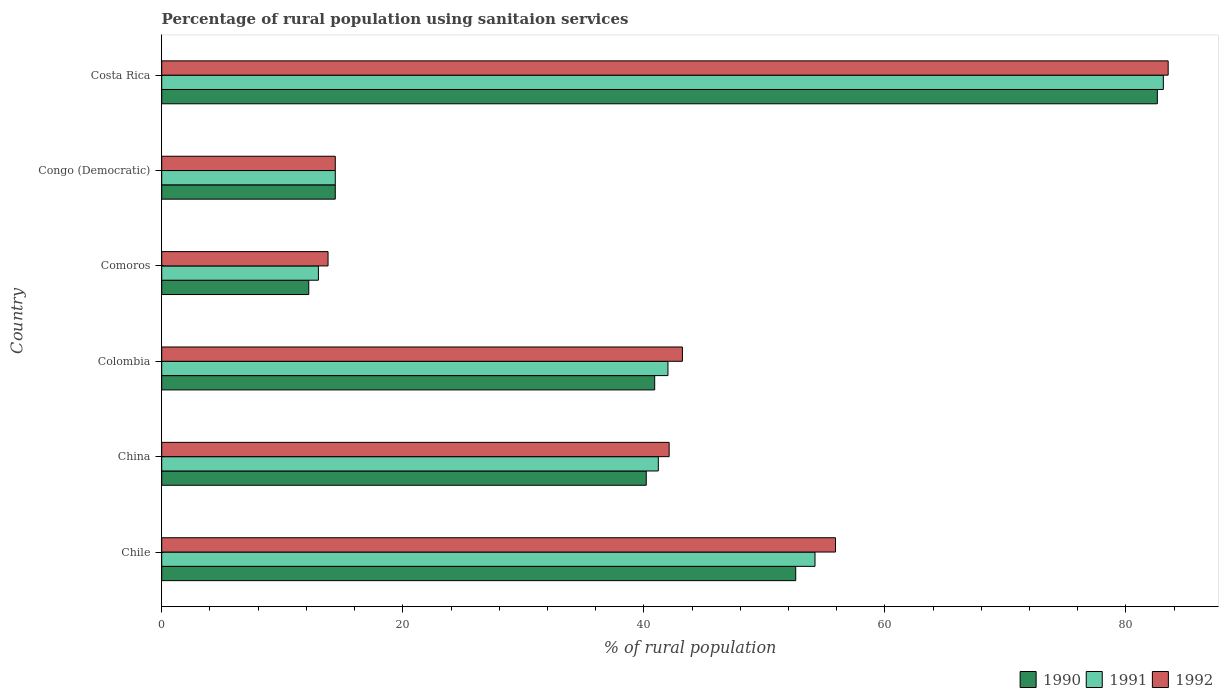How many groups of bars are there?
Your response must be concise. 6. What is the label of the 5th group of bars from the top?
Keep it short and to the point. China. What is the percentage of rural population using sanitaion services in 1992 in Costa Rica?
Your answer should be compact. 83.5. Across all countries, what is the maximum percentage of rural population using sanitaion services in 1990?
Provide a succinct answer. 82.6. Across all countries, what is the minimum percentage of rural population using sanitaion services in 1991?
Ensure brevity in your answer.  13. In which country was the percentage of rural population using sanitaion services in 1991 minimum?
Your answer should be very brief. Comoros. What is the total percentage of rural population using sanitaion services in 1990 in the graph?
Your answer should be very brief. 242.9. What is the difference between the percentage of rural population using sanitaion services in 1991 in China and that in Congo (Democratic)?
Your response must be concise. 26.8. What is the difference between the percentage of rural population using sanitaion services in 1990 in China and the percentage of rural population using sanitaion services in 1992 in Chile?
Make the answer very short. -15.7. What is the average percentage of rural population using sanitaion services in 1990 per country?
Offer a terse response. 40.48. What is the difference between the percentage of rural population using sanitaion services in 1991 and percentage of rural population using sanitaion services in 1990 in Chile?
Provide a short and direct response. 1.6. What is the ratio of the percentage of rural population using sanitaion services in 1992 in Congo (Democratic) to that in Costa Rica?
Offer a terse response. 0.17. Is the percentage of rural population using sanitaion services in 1991 in Chile less than that in Costa Rica?
Give a very brief answer. Yes. Is the difference between the percentage of rural population using sanitaion services in 1991 in China and Colombia greater than the difference between the percentage of rural population using sanitaion services in 1990 in China and Colombia?
Give a very brief answer. No. What is the difference between the highest and the second highest percentage of rural population using sanitaion services in 1990?
Offer a very short reply. 30. What is the difference between the highest and the lowest percentage of rural population using sanitaion services in 1990?
Give a very brief answer. 70.4. In how many countries, is the percentage of rural population using sanitaion services in 1992 greater than the average percentage of rural population using sanitaion services in 1992 taken over all countries?
Keep it short and to the point. 3. Is the sum of the percentage of rural population using sanitaion services in 1992 in China and Costa Rica greater than the maximum percentage of rural population using sanitaion services in 1990 across all countries?
Your response must be concise. Yes. How many countries are there in the graph?
Give a very brief answer. 6. Are the values on the major ticks of X-axis written in scientific E-notation?
Ensure brevity in your answer.  No. Does the graph contain grids?
Offer a very short reply. No. Where does the legend appear in the graph?
Offer a very short reply. Bottom right. How many legend labels are there?
Provide a succinct answer. 3. What is the title of the graph?
Your response must be concise. Percentage of rural population using sanitaion services. What is the label or title of the X-axis?
Your answer should be very brief. % of rural population. What is the label or title of the Y-axis?
Provide a succinct answer. Country. What is the % of rural population in 1990 in Chile?
Offer a terse response. 52.6. What is the % of rural population in 1991 in Chile?
Ensure brevity in your answer.  54.2. What is the % of rural population of 1992 in Chile?
Make the answer very short. 55.9. What is the % of rural population in 1990 in China?
Keep it short and to the point. 40.2. What is the % of rural population in 1991 in China?
Your response must be concise. 41.2. What is the % of rural population of 1992 in China?
Give a very brief answer. 42.1. What is the % of rural population of 1990 in Colombia?
Give a very brief answer. 40.9. What is the % of rural population in 1992 in Colombia?
Keep it short and to the point. 43.2. What is the % of rural population of 1991 in Comoros?
Your answer should be compact. 13. What is the % of rural population of 1992 in Comoros?
Ensure brevity in your answer.  13.8. What is the % of rural population in 1991 in Congo (Democratic)?
Your response must be concise. 14.4. What is the % of rural population in 1990 in Costa Rica?
Your answer should be very brief. 82.6. What is the % of rural population in 1991 in Costa Rica?
Provide a succinct answer. 83.1. What is the % of rural population of 1992 in Costa Rica?
Keep it short and to the point. 83.5. Across all countries, what is the maximum % of rural population in 1990?
Provide a short and direct response. 82.6. Across all countries, what is the maximum % of rural population of 1991?
Ensure brevity in your answer.  83.1. Across all countries, what is the maximum % of rural population in 1992?
Your response must be concise. 83.5. What is the total % of rural population in 1990 in the graph?
Offer a terse response. 242.9. What is the total % of rural population of 1991 in the graph?
Provide a short and direct response. 247.9. What is the total % of rural population in 1992 in the graph?
Your answer should be compact. 252.9. What is the difference between the % of rural population in 1990 in Chile and that in China?
Provide a succinct answer. 12.4. What is the difference between the % of rural population in 1992 in Chile and that in China?
Make the answer very short. 13.8. What is the difference between the % of rural population in 1990 in Chile and that in Colombia?
Keep it short and to the point. 11.7. What is the difference between the % of rural population of 1991 in Chile and that in Colombia?
Your response must be concise. 12.2. What is the difference between the % of rural population of 1990 in Chile and that in Comoros?
Ensure brevity in your answer.  40.4. What is the difference between the % of rural population of 1991 in Chile and that in Comoros?
Provide a succinct answer. 41.2. What is the difference between the % of rural population of 1992 in Chile and that in Comoros?
Your answer should be compact. 42.1. What is the difference between the % of rural population in 1990 in Chile and that in Congo (Democratic)?
Provide a succinct answer. 38.2. What is the difference between the % of rural population of 1991 in Chile and that in Congo (Democratic)?
Your response must be concise. 39.8. What is the difference between the % of rural population in 1992 in Chile and that in Congo (Democratic)?
Make the answer very short. 41.5. What is the difference between the % of rural population of 1990 in Chile and that in Costa Rica?
Your answer should be very brief. -30. What is the difference between the % of rural population in 1991 in Chile and that in Costa Rica?
Make the answer very short. -28.9. What is the difference between the % of rural population in 1992 in Chile and that in Costa Rica?
Ensure brevity in your answer.  -27.6. What is the difference between the % of rural population in 1990 in China and that in Colombia?
Your answer should be compact. -0.7. What is the difference between the % of rural population in 1991 in China and that in Colombia?
Keep it short and to the point. -0.8. What is the difference between the % of rural population in 1990 in China and that in Comoros?
Provide a short and direct response. 28. What is the difference between the % of rural population in 1991 in China and that in Comoros?
Provide a succinct answer. 28.2. What is the difference between the % of rural population of 1992 in China and that in Comoros?
Keep it short and to the point. 28.3. What is the difference between the % of rural population of 1990 in China and that in Congo (Democratic)?
Offer a terse response. 25.8. What is the difference between the % of rural population in 1991 in China and that in Congo (Democratic)?
Ensure brevity in your answer.  26.8. What is the difference between the % of rural population of 1992 in China and that in Congo (Democratic)?
Offer a very short reply. 27.7. What is the difference between the % of rural population in 1990 in China and that in Costa Rica?
Give a very brief answer. -42.4. What is the difference between the % of rural population of 1991 in China and that in Costa Rica?
Your response must be concise. -41.9. What is the difference between the % of rural population of 1992 in China and that in Costa Rica?
Your answer should be very brief. -41.4. What is the difference between the % of rural population in 1990 in Colombia and that in Comoros?
Your answer should be compact. 28.7. What is the difference between the % of rural population of 1991 in Colombia and that in Comoros?
Your answer should be compact. 29. What is the difference between the % of rural population in 1992 in Colombia and that in Comoros?
Your answer should be compact. 29.4. What is the difference between the % of rural population in 1990 in Colombia and that in Congo (Democratic)?
Provide a succinct answer. 26.5. What is the difference between the % of rural population of 1991 in Colombia and that in Congo (Democratic)?
Keep it short and to the point. 27.6. What is the difference between the % of rural population in 1992 in Colombia and that in Congo (Democratic)?
Provide a succinct answer. 28.8. What is the difference between the % of rural population in 1990 in Colombia and that in Costa Rica?
Provide a succinct answer. -41.7. What is the difference between the % of rural population of 1991 in Colombia and that in Costa Rica?
Keep it short and to the point. -41.1. What is the difference between the % of rural population of 1992 in Colombia and that in Costa Rica?
Make the answer very short. -40.3. What is the difference between the % of rural population in 1990 in Comoros and that in Congo (Democratic)?
Your response must be concise. -2.2. What is the difference between the % of rural population in 1991 in Comoros and that in Congo (Democratic)?
Offer a very short reply. -1.4. What is the difference between the % of rural population of 1990 in Comoros and that in Costa Rica?
Your answer should be compact. -70.4. What is the difference between the % of rural population of 1991 in Comoros and that in Costa Rica?
Offer a very short reply. -70.1. What is the difference between the % of rural population in 1992 in Comoros and that in Costa Rica?
Your answer should be compact. -69.7. What is the difference between the % of rural population in 1990 in Congo (Democratic) and that in Costa Rica?
Provide a short and direct response. -68.2. What is the difference between the % of rural population in 1991 in Congo (Democratic) and that in Costa Rica?
Make the answer very short. -68.7. What is the difference between the % of rural population of 1992 in Congo (Democratic) and that in Costa Rica?
Give a very brief answer. -69.1. What is the difference between the % of rural population of 1990 in Chile and the % of rural population of 1991 in China?
Provide a succinct answer. 11.4. What is the difference between the % of rural population in 1990 in Chile and the % of rural population in 1992 in China?
Offer a very short reply. 10.5. What is the difference between the % of rural population of 1990 in Chile and the % of rural population of 1991 in Colombia?
Offer a very short reply. 10.6. What is the difference between the % of rural population of 1990 in Chile and the % of rural population of 1992 in Colombia?
Make the answer very short. 9.4. What is the difference between the % of rural population of 1990 in Chile and the % of rural population of 1991 in Comoros?
Offer a terse response. 39.6. What is the difference between the % of rural population in 1990 in Chile and the % of rural population in 1992 in Comoros?
Ensure brevity in your answer.  38.8. What is the difference between the % of rural population in 1991 in Chile and the % of rural population in 1992 in Comoros?
Your answer should be compact. 40.4. What is the difference between the % of rural population of 1990 in Chile and the % of rural population of 1991 in Congo (Democratic)?
Ensure brevity in your answer.  38.2. What is the difference between the % of rural population in 1990 in Chile and the % of rural population in 1992 in Congo (Democratic)?
Your answer should be compact. 38.2. What is the difference between the % of rural population of 1991 in Chile and the % of rural population of 1992 in Congo (Democratic)?
Your answer should be very brief. 39.8. What is the difference between the % of rural population in 1990 in Chile and the % of rural population in 1991 in Costa Rica?
Offer a terse response. -30.5. What is the difference between the % of rural population of 1990 in Chile and the % of rural population of 1992 in Costa Rica?
Keep it short and to the point. -30.9. What is the difference between the % of rural population in 1991 in Chile and the % of rural population in 1992 in Costa Rica?
Your answer should be compact. -29.3. What is the difference between the % of rural population of 1990 in China and the % of rural population of 1992 in Colombia?
Ensure brevity in your answer.  -3. What is the difference between the % of rural population in 1991 in China and the % of rural population in 1992 in Colombia?
Make the answer very short. -2. What is the difference between the % of rural population in 1990 in China and the % of rural population in 1991 in Comoros?
Offer a very short reply. 27.2. What is the difference between the % of rural population of 1990 in China and the % of rural population of 1992 in Comoros?
Provide a short and direct response. 26.4. What is the difference between the % of rural population in 1991 in China and the % of rural population in 1992 in Comoros?
Ensure brevity in your answer.  27.4. What is the difference between the % of rural population in 1990 in China and the % of rural population in 1991 in Congo (Democratic)?
Ensure brevity in your answer.  25.8. What is the difference between the % of rural population of 1990 in China and the % of rural population of 1992 in Congo (Democratic)?
Offer a terse response. 25.8. What is the difference between the % of rural population of 1991 in China and the % of rural population of 1992 in Congo (Democratic)?
Give a very brief answer. 26.8. What is the difference between the % of rural population of 1990 in China and the % of rural population of 1991 in Costa Rica?
Your answer should be very brief. -42.9. What is the difference between the % of rural population of 1990 in China and the % of rural population of 1992 in Costa Rica?
Ensure brevity in your answer.  -43.3. What is the difference between the % of rural population of 1991 in China and the % of rural population of 1992 in Costa Rica?
Make the answer very short. -42.3. What is the difference between the % of rural population in 1990 in Colombia and the % of rural population in 1991 in Comoros?
Offer a very short reply. 27.9. What is the difference between the % of rural population in 1990 in Colombia and the % of rural population in 1992 in Comoros?
Your answer should be compact. 27.1. What is the difference between the % of rural population in 1991 in Colombia and the % of rural population in 1992 in Comoros?
Your answer should be compact. 28.2. What is the difference between the % of rural population of 1990 in Colombia and the % of rural population of 1992 in Congo (Democratic)?
Make the answer very short. 26.5. What is the difference between the % of rural population of 1991 in Colombia and the % of rural population of 1992 in Congo (Democratic)?
Keep it short and to the point. 27.6. What is the difference between the % of rural population in 1990 in Colombia and the % of rural population in 1991 in Costa Rica?
Ensure brevity in your answer.  -42.2. What is the difference between the % of rural population of 1990 in Colombia and the % of rural population of 1992 in Costa Rica?
Offer a terse response. -42.6. What is the difference between the % of rural population of 1991 in Colombia and the % of rural population of 1992 in Costa Rica?
Provide a short and direct response. -41.5. What is the difference between the % of rural population in 1990 in Comoros and the % of rural population in 1992 in Congo (Democratic)?
Keep it short and to the point. -2.2. What is the difference between the % of rural population in 1991 in Comoros and the % of rural population in 1992 in Congo (Democratic)?
Provide a short and direct response. -1.4. What is the difference between the % of rural population in 1990 in Comoros and the % of rural population in 1991 in Costa Rica?
Make the answer very short. -70.9. What is the difference between the % of rural population in 1990 in Comoros and the % of rural population in 1992 in Costa Rica?
Offer a terse response. -71.3. What is the difference between the % of rural population of 1991 in Comoros and the % of rural population of 1992 in Costa Rica?
Keep it short and to the point. -70.5. What is the difference between the % of rural population in 1990 in Congo (Democratic) and the % of rural population in 1991 in Costa Rica?
Your answer should be compact. -68.7. What is the difference between the % of rural population in 1990 in Congo (Democratic) and the % of rural population in 1992 in Costa Rica?
Your response must be concise. -69.1. What is the difference between the % of rural population of 1991 in Congo (Democratic) and the % of rural population of 1992 in Costa Rica?
Offer a very short reply. -69.1. What is the average % of rural population in 1990 per country?
Offer a terse response. 40.48. What is the average % of rural population of 1991 per country?
Keep it short and to the point. 41.32. What is the average % of rural population of 1992 per country?
Provide a short and direct response. 42.15. What is the difference between the % of rural population in 1990 and % of rural population in 1991 in Chile?
Keep it short and to the point. -1.6. What is the difference between the % of rural population in 1991 and % of rural population in 1992 in Chile?
Offer a very short reply. -1.7. What is the difference between the % of rural population of 1990 and % of rural population of 1992 in Colombia?
Your response must be concise. -2.3. What is the difference between the % of rural population in 1991 and % of rural population in 1992 in Colombia?
Provide a succinct answer. -1.2. What is the difference between the % of rural population in 1991 and % of rural population in 1992 in Comoros?
Provide a short and direct response. -0.8. What is the difference between the % of rural population in 1990 and % of rural population in 1991 in Congo (Democratic)?
Your response must be concise. 0. What is the difference between the % of rural population in 1990 and % of rural population in 1992 in Congo (Democratic)?
Offer a very short reply. 0. What is the difference between the % of rural population of 1990 and % of rural population of 1991 in Costa Rica?
Offer a very short reply. -0.5. What is the ratio of the % of rural population of 1990 in Chile to that in China?
Offer a terse response. 1.31. What is the ratio of the % of rural population of 1991 in Chile to that in China?
Provide a short and direct response. 1.32. What is the ratio of the % of rural population in 1992 in Chile to that in China?
Keep it short and to the point. 1.33. What is the ratio of the % of rural population in 1990 in Chile to that in Colombia?
Your response must be concise. 1.29. What is the ratio of the % of rural population in 1991 in Chile to that in Colombia?
Give a very brief answer. 1.29. What is the ratio of the % of rural population in 1992 in Chile to that in Colombia?
Your response must be concise. 1.29. What is the ratio of the % of rural population of 1990 in Chile to that in Comoros?
Provide a succinct answer. 4.31. What is the ratio of the % of rural population of 1991 in Chile to that in Comoros?
Your answer should be compact. 4.17. What is the ratio of the % of rural population of 1992 in Chile to that in Comoros?
Your answer should be very brief. 4.05. What is the ratio of the % of rural population in 1990 in Chile to that in Congo (Democratic)?
Offer a very short reply. 3.65. What is the ratio of the % of rural population of 1991 in Chile to that in Congo (Democratic)?
Ensure brevity in your answer.  3.76. What is the ratio of the % of rural population of 1992 in Chile to that in Congo (Democratic)?
Provide a succinct answer. 3.88. What is the ratio of the % of rural population in 1990 in Chile to that in Costa Rica?
Provide a short and direct response. 0.64. What is the ratio of the % of rural population in 1991 in Chile to that in Costa Rica?
Ensure brevity in your answer.  0.65. What is the ratio of the % of rural population in 1992 in Chile to that in Costa Rica?
Offer a very short reply. 0.67. What is the ratio of the % of rural population of 1990 in China to that in Colombia?
Ensure brevity in your answer.  0.98. What is the ratio of the % of rural population in 1991 in China to that in Colombia?
Make the answer very short. 0.98. What is the ratio of the % of rural population of 1992 in China to that in Colombia?
Offer a very short reply. 0.97. What is the ratio of the % of rural population of 1990 in China to that in Comoros?
Keep it short and to the point. 3.3. What is the ratio of the % of rural population in 1991 in China to that in Comoros?
Offer a very short reply. 3.17. What is the ratio of the % of rural population in 1992 in China to that in Comoros?
Keep it short and to the point. 3.05. What is the ratio of the % of rural population of 1990 in China to that in Congo (Democratic)?
Ensure brevity in your answer.  2.79. What is the ratio of the % of rural population in 1991 in China to that in Congo (Democratic)?
Give a very brief answer. 2.86. What is the ratio of the % of rural population in 1992 in China to that in Congo (Democratic)?
Provide a short and direct response. 2.92. What is the ratio of the % of rural population in 1990 in China to that in Costa Rica?
Give a very brief answer. 0.49. What is the ratio of the % of rural population in 1991 in China to that in Costa Rica?
Offer a very short reply. 0.5. What is the ratio of the % of rural population in 1992 in China to that in Costa Rica?
Ensure brevity in your answer.  0.5. What is the ratio of the % of rural population in 1990 in Colombia to that in Comoros?
Offer a terse response. 3.35. What is the ratio of the % of rural population of 1991 in Colombia to that in Comoros?
Offer a very short reply. 3.23. What is the ratio of the % of rural population of 1992 in Colombia to that in Comoros?
Provide a short and direct response. 3.13. What is the ratio of the % of rural population in 1990 in Colombia to that in Congo (Democratic)?
Provide a succinct answer. 2.84. What is the ratio of the % of rural population in 1991 in Colombia to that in Congo (Democratic)?
Provide a short and direct response. 2.92. What is the ratio of the % of rural population of 1992 in Colombia to that in Congo (Democratic)?
Ensure brevity in your answer.  3. What is the ratio of the % of rural population in 1990 in Colombia to that in Costa Rica?
Provide a succinct answer. 0.5. What is the ratio of the % of rural population in 1991 in Colombia to that in Costa Rica?
Your answer should be very brief. 0.51. What is the ratio of the % of rural population in 1992 in Colombia to that in Costa Rica?
Give a very brief answer. 0.52. What is the ratio of the % of rural population of 1990 in Comoros to that in Congo (Democratic)?
Provide a short and direct response. 0.85. What is the ratio of the % of rural population of 1991 in Comoros to that in Congo (Democratic)?
Your answer should be compact. 0.9. What is the ratio of the % of rural population in 1990 in Comoros to that in Costa Rica?
Keep it short and to the point. 0.15. What is the ratio of the % of rural population of 1991 in Comoros to that in Costa Rica?
Provide a short and direct response. 0.16. What is the ratio of the % of rural population in 1992 in Comoros to that in Costa Rica?
Your answer should be very brief. 0.17. What is the ratio of the % of rural population in 1990 in Congo (Democratic) to that in Costa Rica?
Offer a very short reply. 0.17. What is the ratio of the % of rural population in 1991 in Congo (Democratic) to that in Costa Rica?
Your answer should be very brief. 0.17. What is the ratio of the % of rural population of 1992 in Congo (Democratic) to that in Costa Rica?
Your answer should be compact. 0.17. What is the difference between the highest and the second highest % of rural population in 1990?
Your answer should be very brief. 30. What is the difference between the highest and the second highest % of rural population in 1991?
Provide a short and direct response. 28.9. What is the difference between the highest and the second highest % of rural population of 1992?
Make the answer very short. 27.6. What is the difference between the highest and the lowest % of rural population in 1990?
Make the answer very short. 70.4. What is the difference between the highest and the lowest % of rural population in 1991?
Keep it short and to the point. 70.1. What is the difference between the highest and the lowest % of rural population of 1992?
Keep it short and to the point. 69.7. 